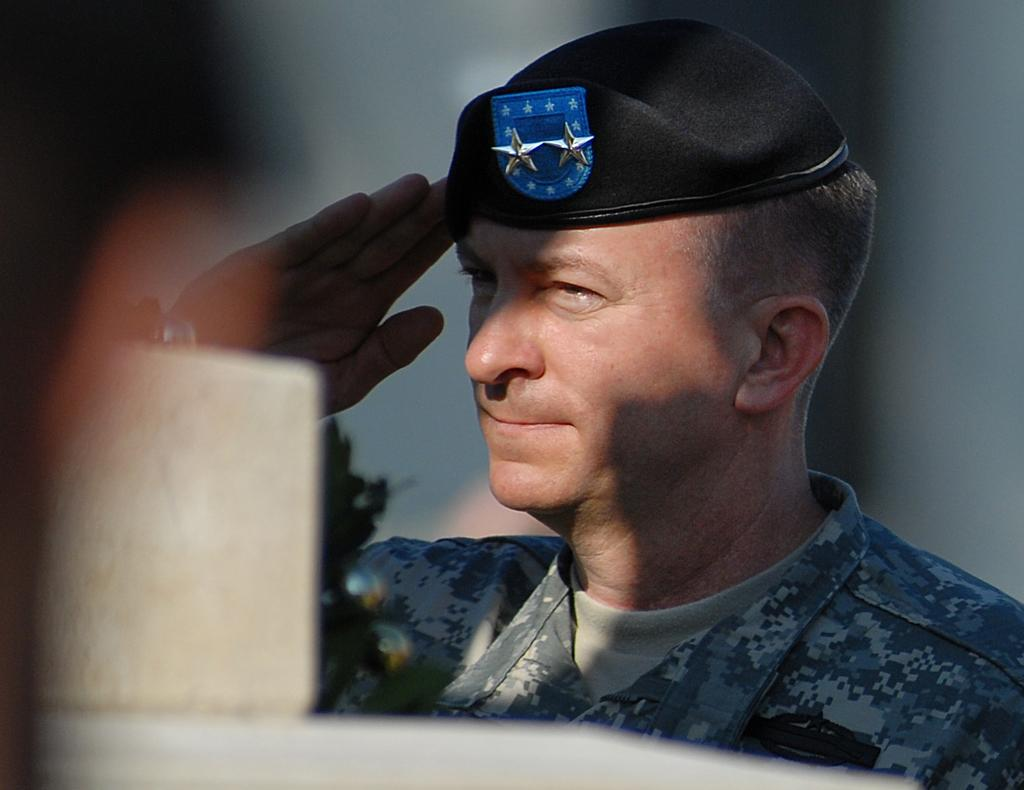Who is the main subject in the image? There is a man in the center of the image. What is the man doing in the image? The man is standing and saluting. What is the man wearing in the image? The man is wearing a uniform. Who is the owner of the things in the image? There are no specific "things" mentioned in the image, so it's not possible to determine who the owner might be. 